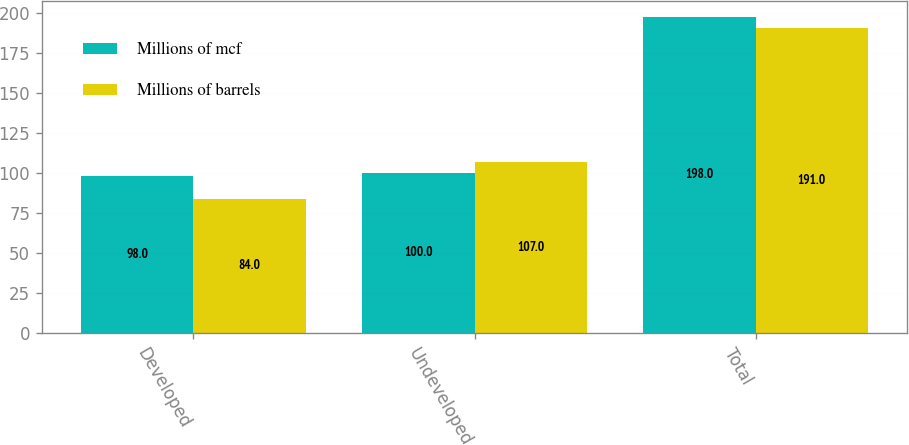Convert chart. <chart><loc_0><loc_0><loc_500><loc_500><stacked_bar_chart><ecel><fcel>Developed<fcel>Undeveloped<fcel>Total<nl><fcel>Millions of mcf<fcel>98<fcel>100<fcel>198<nl><fcel>Millions of barrels<fcel>84<fcel>107<fcel>191<nl></chart> 